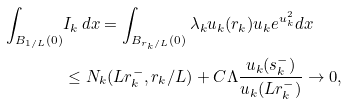Convert formula to latex. <formula><loc_0><loc_0><loc_500><loc_500>\int _ { B _ { 1 / L } ( 0 ) } & I _ { k } \, d x = \int _ { B _ { r _ { k } / L } ( 0 ) } \lambda _ { k } u _ { k } ( r _ { k } ) u _ { k } e ^ { u _ { k } ^ { 2 } } d x \\ & \leq N _ { k } ( L r _ { k } ^ { - } , r _ { k } / L ) + C \Lambda \frac { u _ { k } ( s _ { k } ^ { - } ) } { u _ { k } ( L r _ { k } ^ { - } ) } \rightarrow 0 ,</formula> 